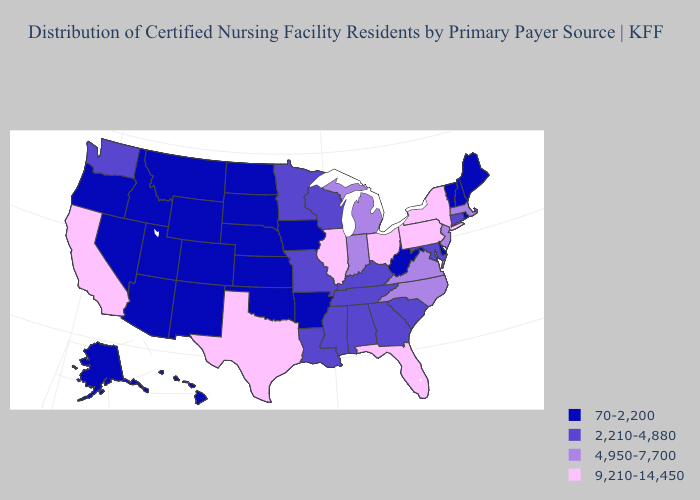Name the states that have a value in the range 70-2,200?
Answer briefly. Alaska, Arizona, Arkansas, Colorado, Delaware, Hawaii, Idaho, Iowa, Kansas, Maine, Montana, Nebraska, Nevada, New Hampshire, New Mexico, North Dakota, Oklahoma, Oregon, Rhode Island, South Dakota, Utah, Vermont, West Virginia, Wyoming. What is the highest value in the Northeast ?
Quick response, please. 9,210-14,450. Name the states that have a value in the range 9,210-14,450?
Short answer required. California, Florida, Illinois, New York, Ohio, Pennsylvania, Texas. Does Alaska have a higher value than Arkansas?
Quick response, please. No. What is the lowest value in the South?
Write a very short answer. 70-2,200. Name the states that have a value in the range 4,950-7,700?
Keep it brief. Indiana, Massachusetts, Michigan, New Jersey, North Carolina, Virginia. What is the highest value in the USA?
Quick response, please. 9,210-14,450. Name the states that have a value in the range 9,210-14,450?
Short answer required. California, Florida, Illinois, New York, Ohio, Pennsylvania, Texas. Name the states that have a value in the range 2,210-4,880?
Short answer required. Alabama, Connecticut, Georgia, Kentucky, Louisiana, Maryland, Minnesota, Mississippi, Missouri, South Carolina, Tennessee, Washington, Wisconsin. Is the legend a continuous bar?
Keep it brief. No. Name the states that have a value in the range 2,210-4,880?
Give a very brief answer. Alabama, Connecticut, Georgia, Kentucky, Louisiana, Maryland, Minnesota, Mississippi, Missouri, South Carolina, Tennessee, Washington, Wisconsin. What is the highest value in states that border Oregon?
Quick response, please. 9,210-14,450. Does Arizona have the highest value in the West?
Keep it brief. No. Is the legend a continuous bar?
Keep it brief. No. Among the states that border New Hampshire , which have the lowest value?
Write a very short answer. Maine, Vermont. 